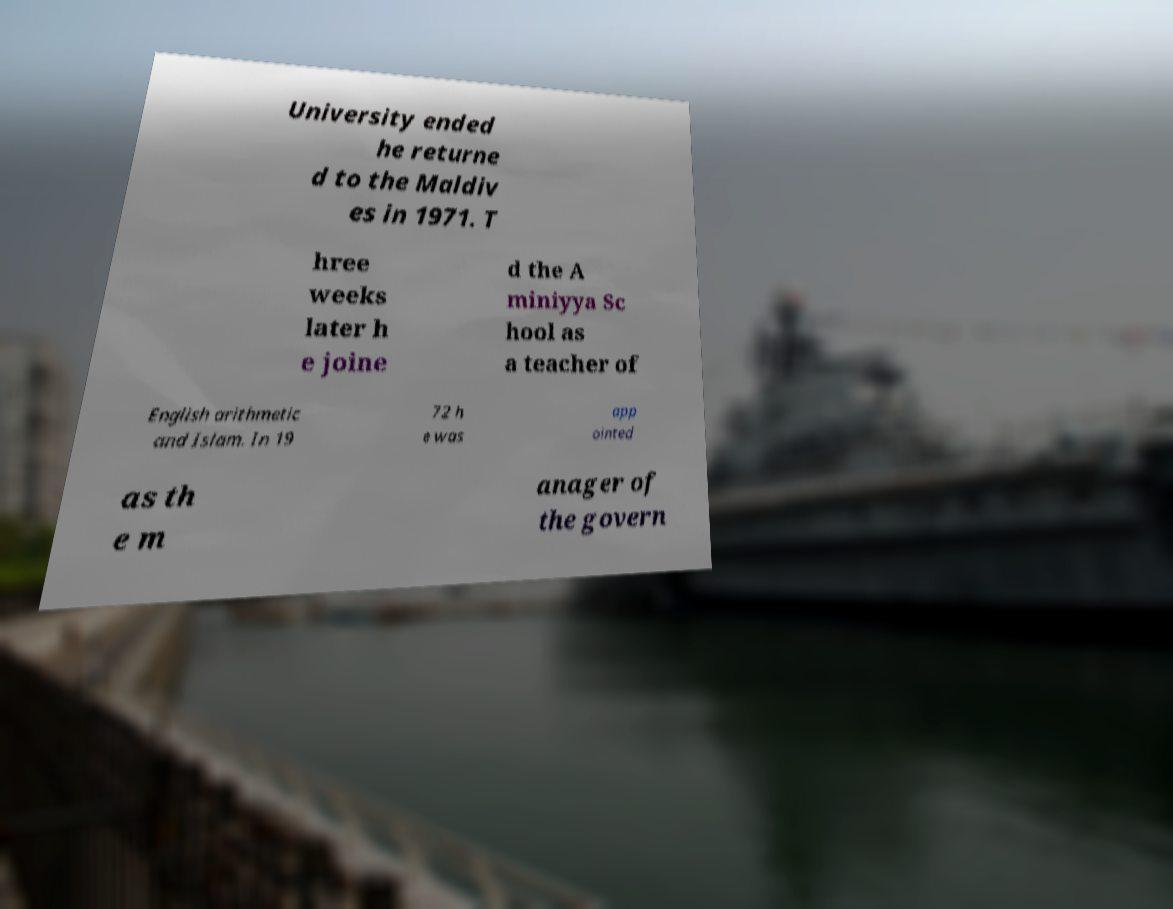I need the written content from this picture converted into text. Can you do that? University ended he returne d to the Maldiv es in 1971. T hree weeks later h e joine d the A miniyya Sc hool as a teacher of English arithmetic and Islam. In 19 72 h e was app ointed as th e m anager of the govern 